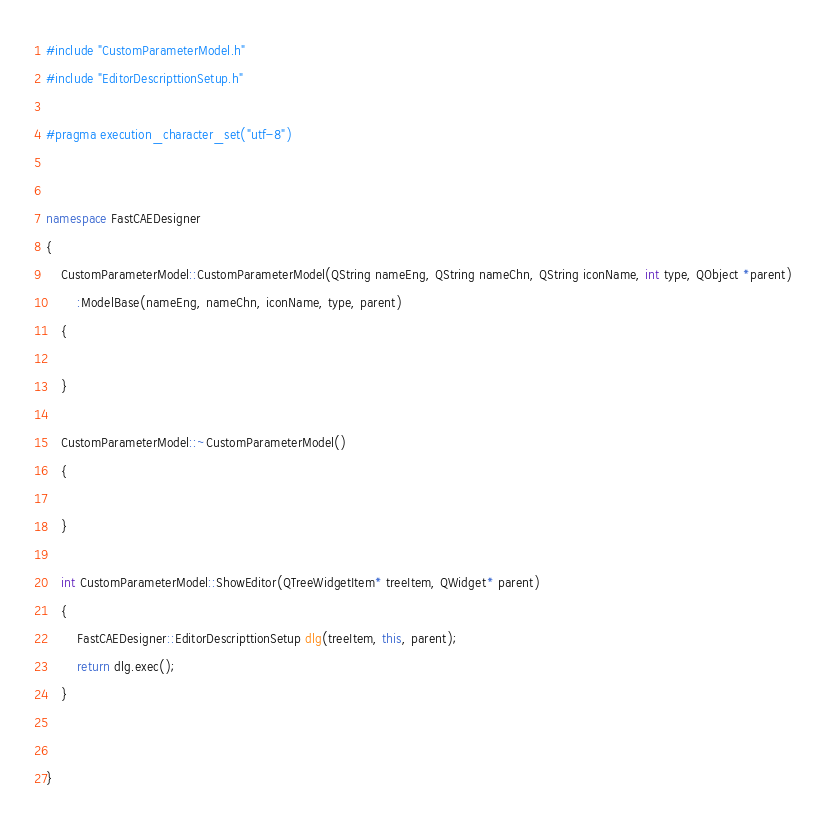Convert code to text. <code><loc_0><loc_0><loc_500><loc_500><_C++_>#include "CustomParameterModel.h"
#include "EditorDescripttionSetup.h"

#pragma execution_character_set("utf-8")


namespace FastCAEDesigner
{
	CustomParameterModel::CustomParameterModel(QString nameEng, QString nameChn, QString iconName, int type, QObject *parent)
		:ModelBase(nameEng, nameChn, iconName, type, parent)
	{

	}

	CustomParameterModel::~CustomParameterModel()
	{

	}

	int CustomParameterModel::ShowEditor(QTreeWidgetItem* treeItem, QWidget* parent)
	{
		FastCAEDesigner::EditorDescripttionSetup dlg(treeItem, this, parent);
		return dlg.exec();
	}

	
}</code> 